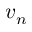<formula> <loc_0><loc_0><loc_500><loc_500>v _ { n }</formula> 